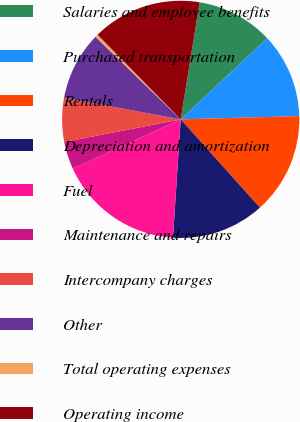Convert chart to OTSL. <chart><loc_0><loc_0><loc_500><loc_500><pie_chart><fcel>Salaries and employee benefits<fcel>Purchased transportation<fcel>Rentals<fcel>Depreciation and amortization<fcel>Fuel<fcel>Maintenance and repairs<fcel>Intercompany charges<fcel>Other<fcel>Total operating expenses<fcel>Operating income<nl><fcel>10.45%<fcel>11.56%<fcel>13.8%<fcel>12.68%<fcel>17.15%<fcel>3.75%<fcel>5.98%<fcel>9.33%<fcel>0.4%<fcel>14.91%<nl></chart> 